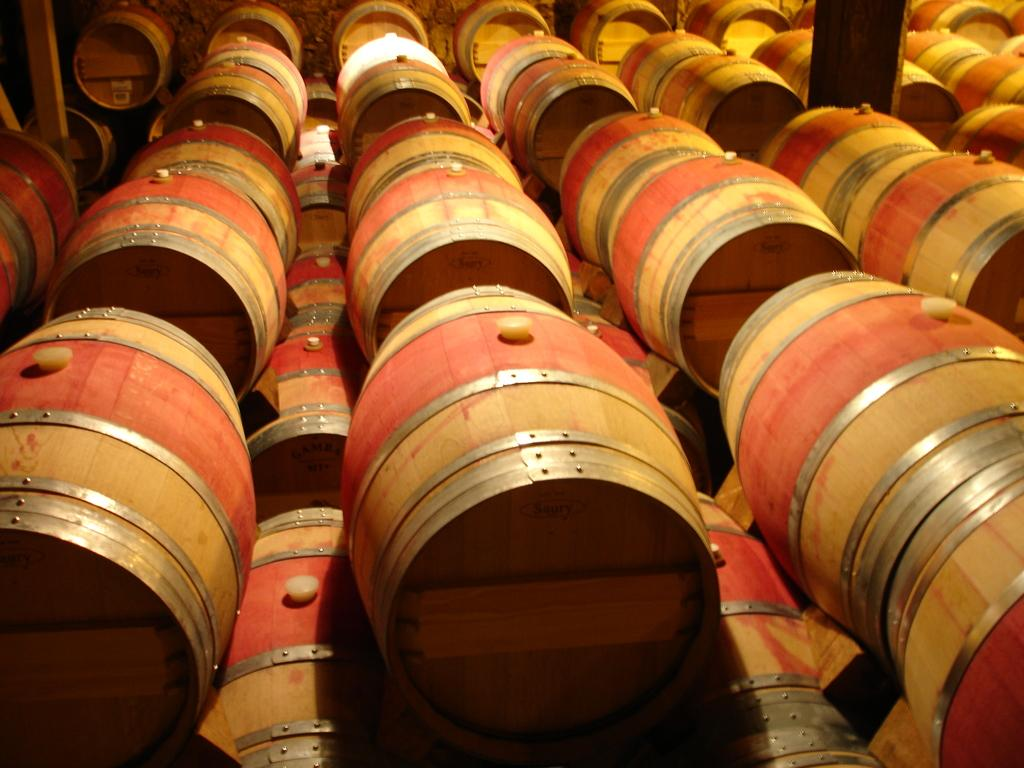What type of musical instruments are present in the image? There are many drums in the image. What colors can be seen on the drums in the image? The drums are in brown color and orange color. Can you tell me who the writer is in the image? There is no writer present in the image; it features drums in brown and orange colors. What type of material is the leather used for in the image? There is no leather present in the image; it only features drums. 